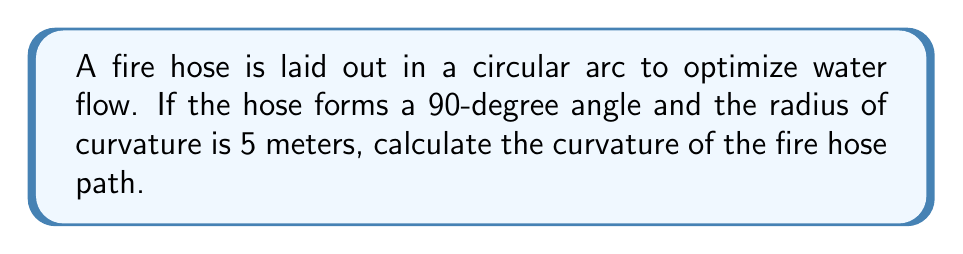What is the answer to this math problem? To solve this problem, we'll follow these steps:

1) The curvature $\kappa$ of a circle is defined as the reciprocal of its radius $r$:

   $$\kappa = \frac{1}{r}$$

2) We're given that the radius of curvature is 5 meters:

   $$r = 5\text{ m}$$

3) Substituting this into our curvature formula:

   $$\kappa = \frac{1}{5\text{ m}}$$

4) Simplifying:

   $$\kappa = 0.2\text{ m}^{-1}$$

Note: The units of curvature are the inverse of length units, in this case m^-1 (per meter).

This curvature value indicates how sharply the fire hose is bending. A higher value would indicate a sharper bend, while a lower value would indicate a more gradual curve. This information can be used to optimize water flow and pressure in the fire hose.
Answer: $0.2\text{ m}^{-1}$ 